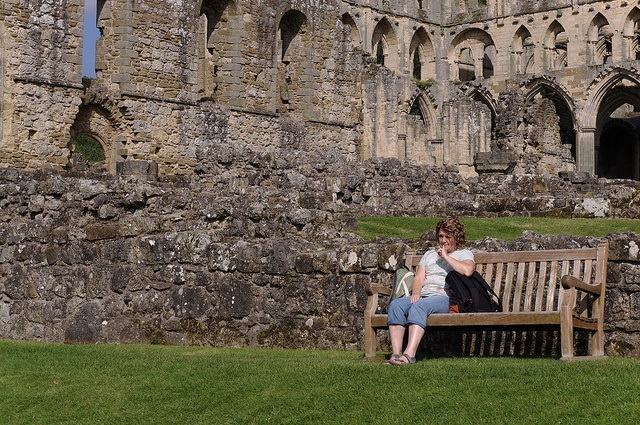Describe the objects in this image and their specific colors. I can see bench in black, gray, maroon, and darkgray tones, people in black, lightpink, lightgray, and darkgray tones, and backpack in black, gray, maroon, and brown tones in this image. 